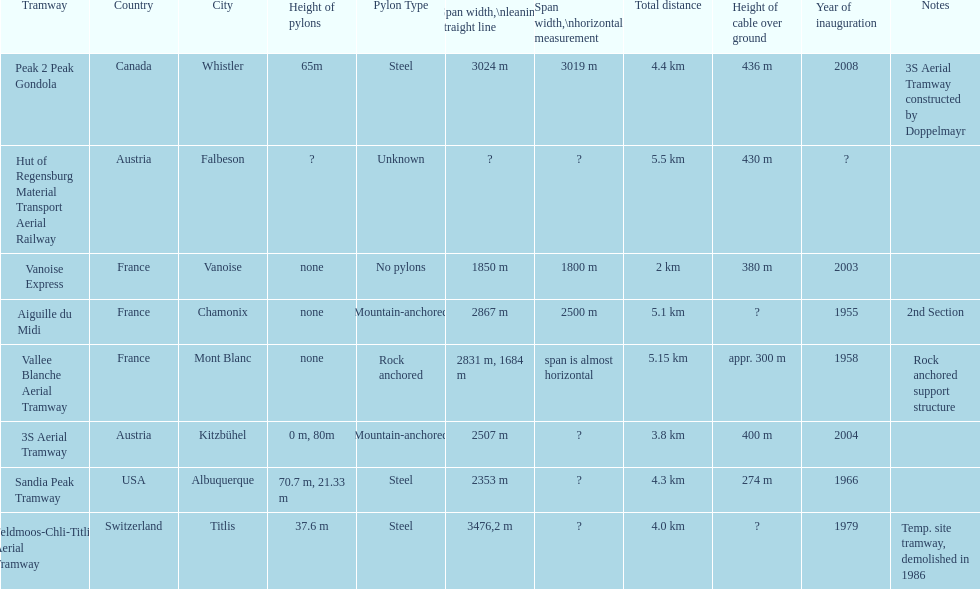Which tramway was built directly before the 3s aeriral tramway? Vanoise Express. 